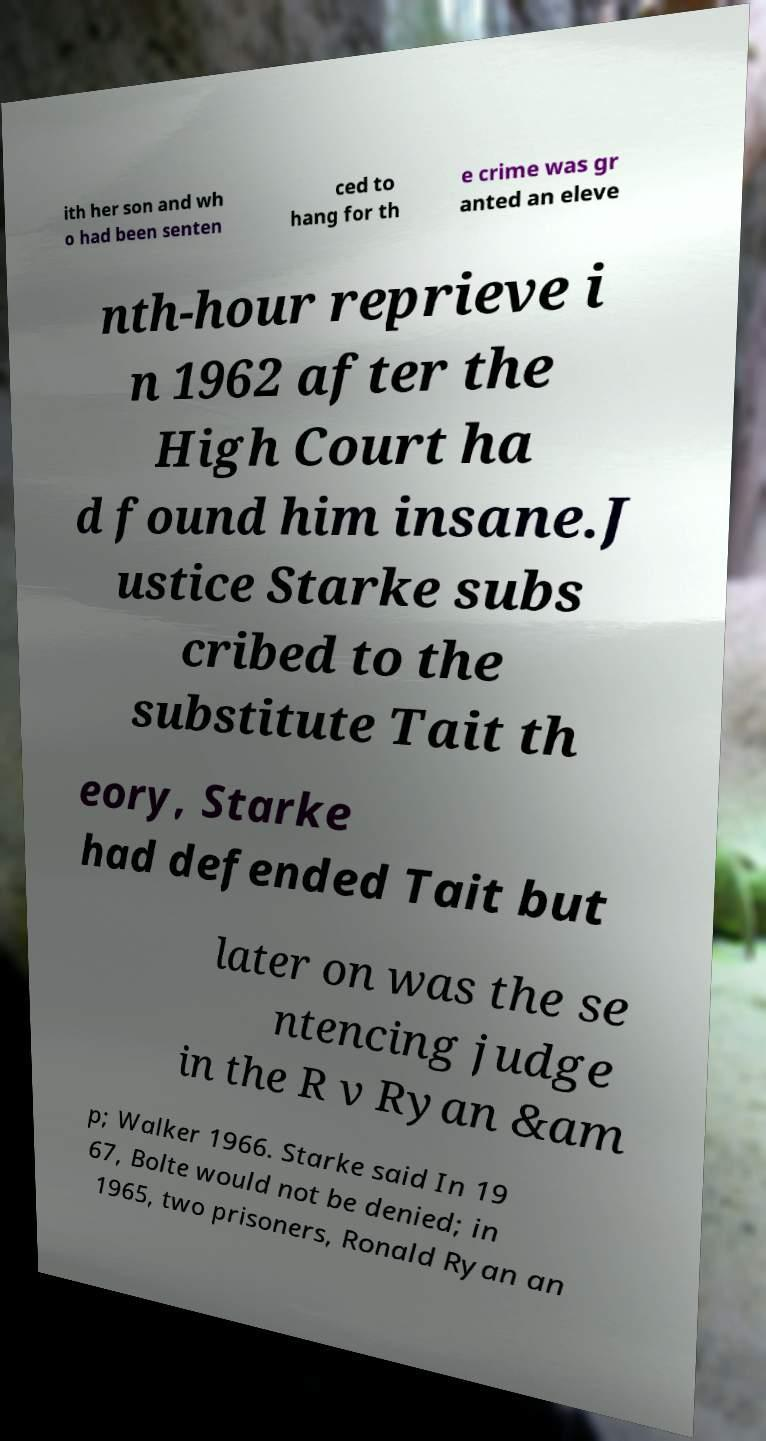I need the written content from this picture converted into text. Can you do that? ith her son and wh o had been senten ced to hang for th e crime was gr anted an eleve nth-hour reprieve i n 1962 after the High Court ha d found him insane.J ustice Starke subs cribed to the substitute Tait th eory, Starke had defended Tait but later on was the se ntencing judge in the R v Ryan &am p; Walker 1966. Starke said In 19 67, Bolte would not be denied; in 1965, two prisoners, Ronald Ryan an 